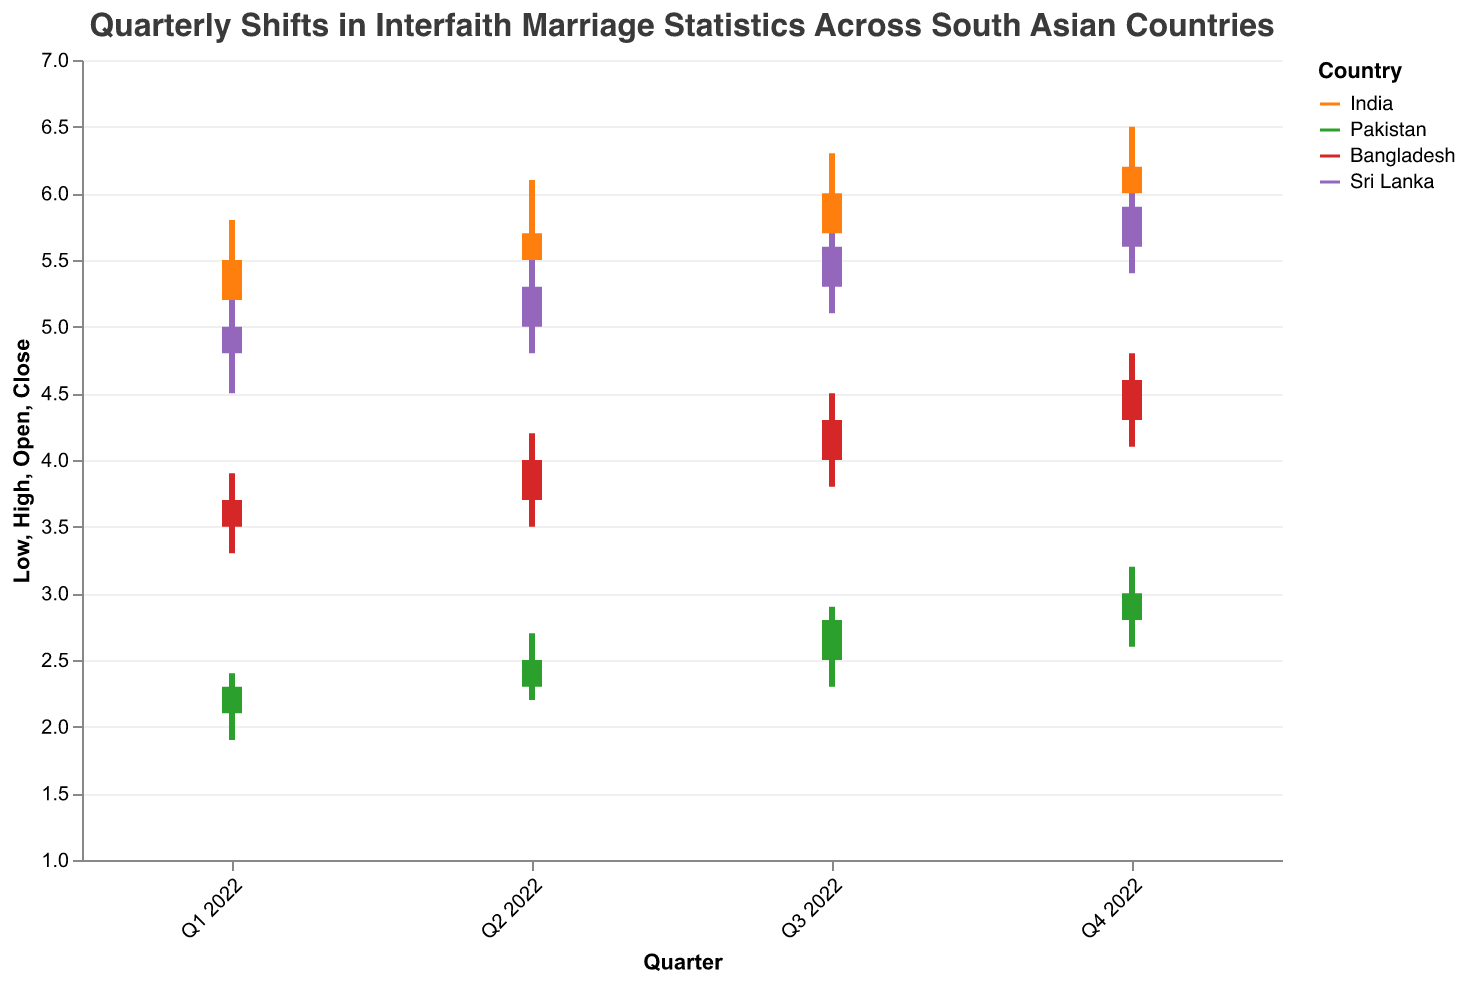What is the title of the figure? The title of the figure can be found at the top. It reads: "Quarterly Shifts in Interfaith Marriage Statistics Across South Asian Countries"
Answer: Quarterly Shifts in Interfaith Marriage Statistics Across South Asian Countries Which country shows the highest value for interfaith marriages in Q4 2022? The Q4 2022 bar with the highest close value belongs to Sri Lanka, reaching 6.2
Answer: Sri Lanka What is the approximate range of the y-axis in the plot? Observing the y-axis, it spans from 1 to 7
Answer: 1 to 7 Which country had the smallest increase in interfaith marriages between Q1 2022 and Q4 2022? Calculate the difference between the Close values in Q4 and Q1 for each country: India (6.2 - 5.5 = 0.7), Pakistan (3.0 - 2.3 = 0.7), Bangladesh (4.6 - 3.7 = 0.9), Sri Lanka (5.9 - 5.0 = 0.9). Both India and Pakistan show the smallest increase of 0.7
Answer: India and Pakistan How did the open values of interfaith marriages for Pakistan compare between Q2 2022 and Q3 2022? To determine the difference: Q3 2022 (2.5) was higher than Q2 2022 (2.3) by 0.2
Answer: 2.5 is 0.2 higher than 2.3 What is the largest high value recorded for any country throughout the quarters? By examining all High values: India's Q4 2022 has the highest value of 6.5
Answer: 6.5 In which quarter did Bangladesh see the highest point of intra-quarter variability? Intra-quarter variability can be calculated as High value minus Low value: 
Q1 2022 (3.9 - 3.3 = 0.6), Q2 2022 (4.2 - 3.5 = 0.7), Q3 2022 (4.5 - 3.8 = 0.7), Q4 2022 (4.8 - 4.1 = 0.7). 
Bangladesh showed the highest variability (0.7) in multiple quarters: Q2, Q3, and Q4.
Answer: Q2 2022, Q3 2022, and Q4 2022 What was the trend in interfaith marriages for Sri Lanka from Q1 to Q4 2022? Examine Sri Lanka's close values per quarter:
Q1 2022 = 5.0, Q2 2022 = 5.3, Q3 2022 = 5.6, Q4 2022 = 5.9. The close values consistently increased each quarter.
Answer: Increasing trend Which country had the least interfaith marriage close value in Q1 2022? Looking at the close values for Q1 2022 across all countries: Pakistan (2.3) is the lowest
Answer: Pakistan 